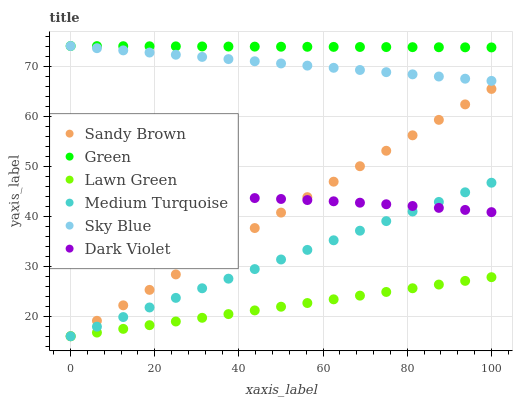Does Lawn Green have the minimum area under the curve?
Answer yes or no. Yes. Does Green have the maximum area under the curve?
Answer yes or no. Yes. Does Dark Violet have the minimum area under the curve?
Answer yes or no. No. Does Dark Violet have the maximum area under the curve?
Answer yes or no. No. Is Sandy Brown the smoothest?
Answer yes or no. Yes. Is Dark Violet the roughest?
Answer yes or no. Yes. Is Green the smoothest?
Answer yes or no. No. Is Green the roughest?
Answer yes or no. No. Does Lawn Green have the lowest value?
Answer yes or no. Yes. Does Dark Violet have the lowest value?
Answer yes or no. No. Does Sky Blue have the highest value?
Answer yes or no. Yes. Does Dark Violet have the highest value?
Answer yes or no. No. Is Lawn Green less than Sky Blue?
Answer yes or no. Yes. Is Sky Blue greater than Sandy Brown?
Answer yes or no. Yes. Does Lawn Green intersect Medium Turquoise?
Answer yes or no. Yes. Is Lawn Green less than Medium Turquoise?
Answer yes or no. No. Is Lawn Green greater than Medium Turquoise?
Answer yes or no. No. Does Lawn Green intersect Sky Blue?
Answer yes or no. No. 